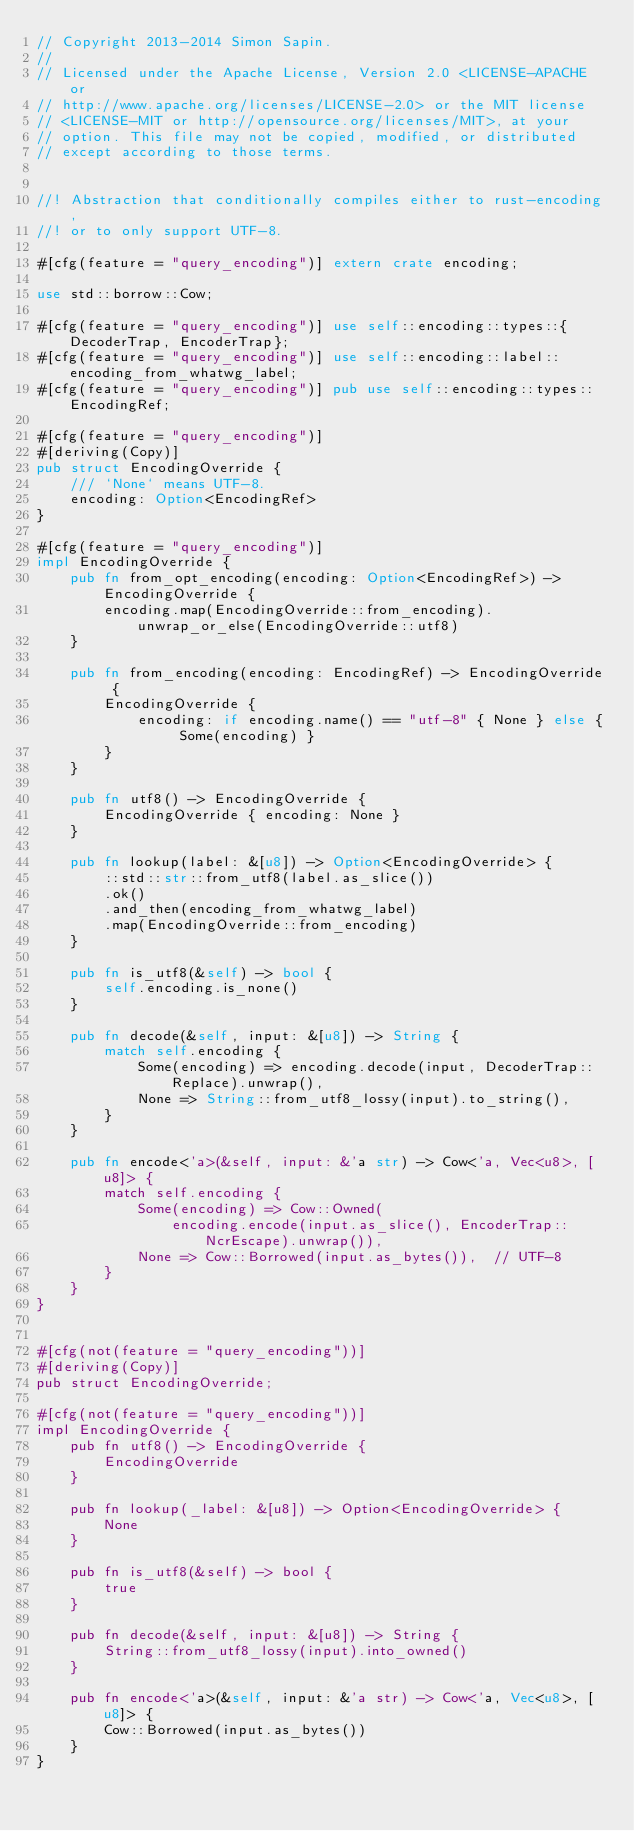<code> <loc_0><loc_0><loc_500><loc_500><_Rust_>// Copyright 2013-2014 Simon Sapin.
//
// Licensed under the Apache License, Version 2.0 <LICENSE-APACHE or
// http://www.apache.org/licenses/LICENSE-2.0> or the MIT license
// <LICENSE-MIT or http://opensource.org/licenses/MIT>, at your
// option. This file may not be copied, modified, or distributed
// except according to those terms.


//! Abstraction that conditionally compiles either to rust-encoding,
//! or to only support UTF-8.

#[cfg(feature = "query_encoding")] extern crate encoding;

use std::borrow::Cow;

#[cfg(feature = "query_encoding")] use self::encoding::types::{DecoderTrap, EncoderTrap};
#[cfg(feature = "query_encoding")] use self::encoding::label::encoding_from_whatwg_label;
#[cfg(feature = "query_encoding")] pub use self::encoding::types::EncodingRef;

#[cfg(feature = "query_encoding")]
#[deriving(Copy)]
pub struct EncodingOverride {
    /// `None` means UTF-8.
    encoding: Option<EncodingRef>
}

#[cfg(feature = "query_encoding")]
impl EncodingOverride {
    pub fn from_opt_encoding(encoding: Option<EncodingRef>) -> EncodingOverride {
        encoding.map(EncodingOverride::from_encoding).unwrap_or_else(EncodingOverride::utf8)
    }

    pub fn from_encoding(encoding: EncodingRef) -> EncodingOverride {
        EncodingOverride {
            encoding: if encoding.name() == "utf-8" { None } else { Some(encoding) }
        }
    }

    pub fn utf8() -> EncodingOverride {
        EncodingOverride { encoding: None }
    }

    pub fn lookup(label: &[u8]) -> Option<EncodingOverride> {
        ::std::str::from_utf8(label.as_slice())
        .ok()
        .and_then(encoding_from_whatwg_label)
        .map(EncodingOverride::from_encoding)
    }

    pub fn is_utf8(&self) -> bool {
        self.encoding.is_none()
    }

    pub fn decode(&self, input: &[u8]) -> String {
        match self.encoding {
            Some(encoding) => encoding.decode(input, DecoderTrap::Replace).unwrap(),
            None => String::from_utf8_lossy(input).to_string(),
        }
    }

    pub fn encode<'a>(&self, input: &'a str) -> Cow<'a, Vec<u8>, [u8]> {
        match self.encoding {
            Some(encoding) => Cow::Owned(
                encoding.encode(input.as_slice(), EncoderTrap::NcrEscape).unwrap()),
            None => Cow::Borrowed(input.as_bytes()),  // UTF-8
        }
    }
}


#[cfg(not(feature = "query_encoding"))]
#[deriving(Copy)]
pub struct EncodingOverride;

#[cfg(not(feature = "query_encoding"))]
impl EncodingOverride {
    pub fn utf8() -> EncodingOverride {
        EncodingOverride
    }

    pub fn lookup(_label: &[u8]) -> Option<EncodingOverride> {
        None
    }

    pub fn is_utf8(&self) -> bool {
        true
    }

    pub fn decode(&self, input: &[u8]) -> String {
        String::from_utf8_lossy(input).into_owned()
    }

    pub fn encode<'a>(&self, input: &'a str) -> Cow<'a, Vec<u8>, [u8]> {
        Cow::Borrowed(input.as_bytes())
    }
}
</code> 